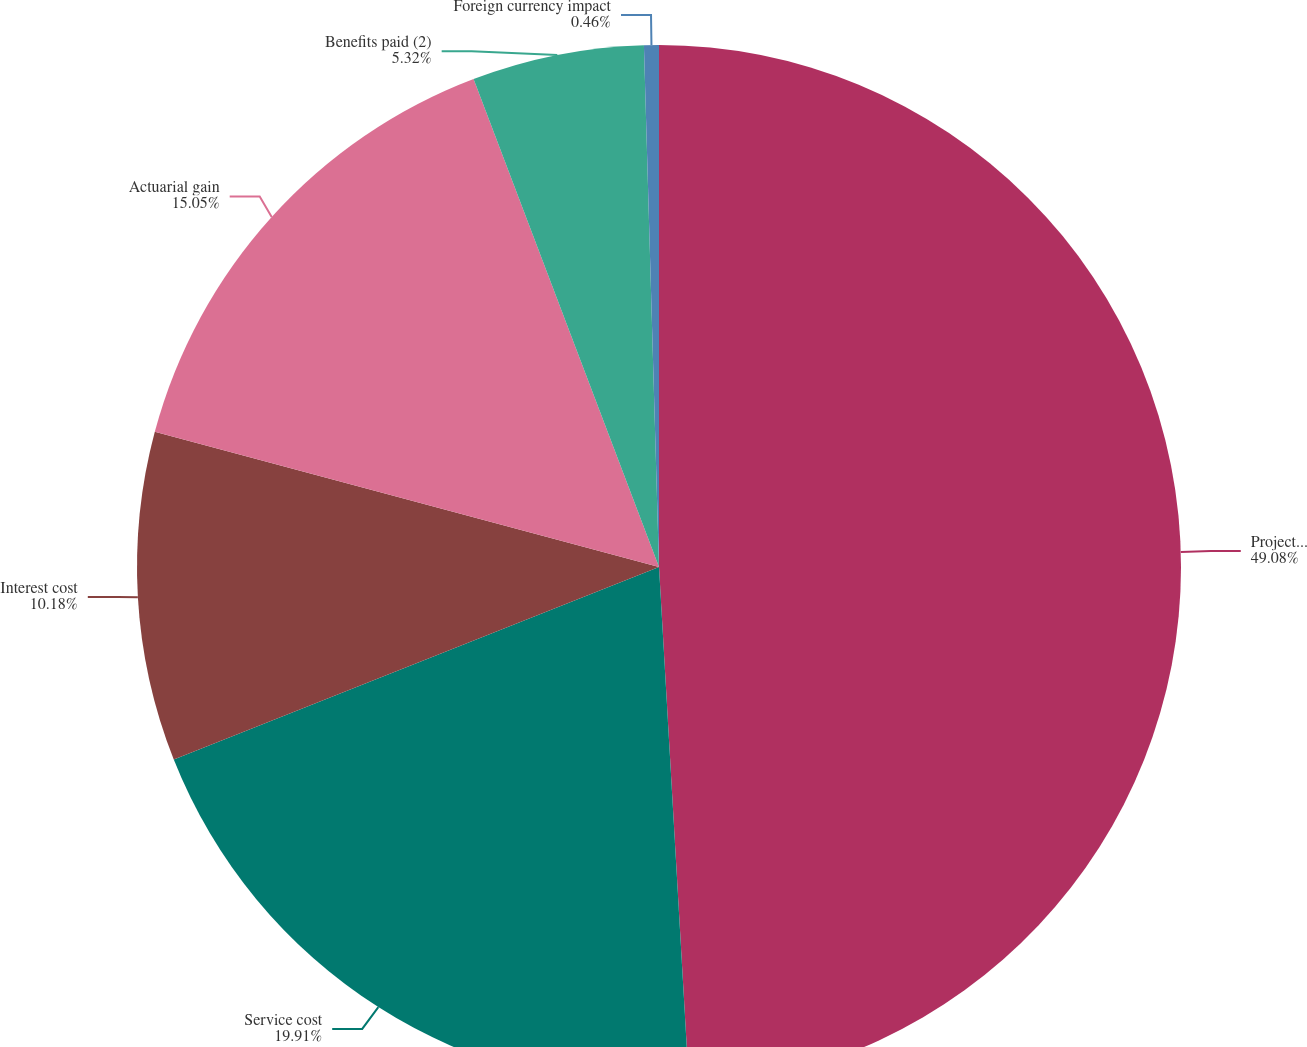<chart> <loc_0><loc_0><loc_500><loc_500><pie_chart><fcel>Projected benefit obligation<fcel>Service cost<fcel>Interest cost<fcel>Actuarial gain<fcel>Benefits paid (2)<fcel>Foreign currency impact<nl><fcel>49.08%<fcel>19.91%<fcel>10.18%<fcel>15.05%<fcel>5.32%<fcel>0.46%<nl></chart> 